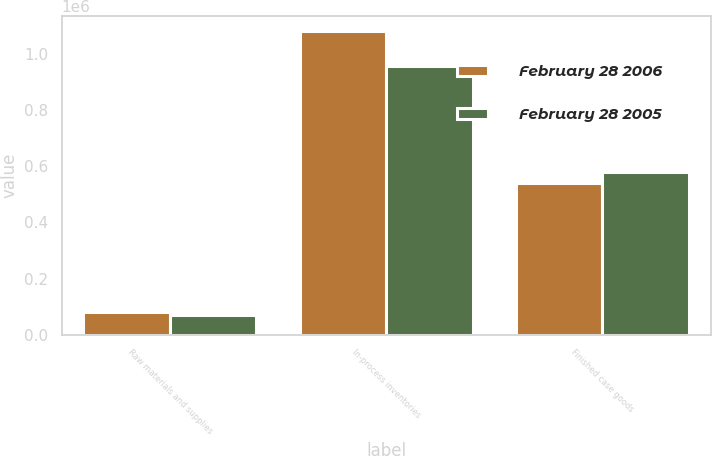Convert chart. <chart><loc_0><loc_0><loc_500><loc_500><stacked_bar_chart><ecel><fcel>Raw materials and supplies<fcel>In-process inventories<fcel>Finished case goods<nl><fcel>February 28 2006<fcel>82366<fcel>1.0813e+06<fcel>540762<nl><fcel>February 28 2005<fcel>71562<fcel>957567<fcel>578606<nl></chart> 